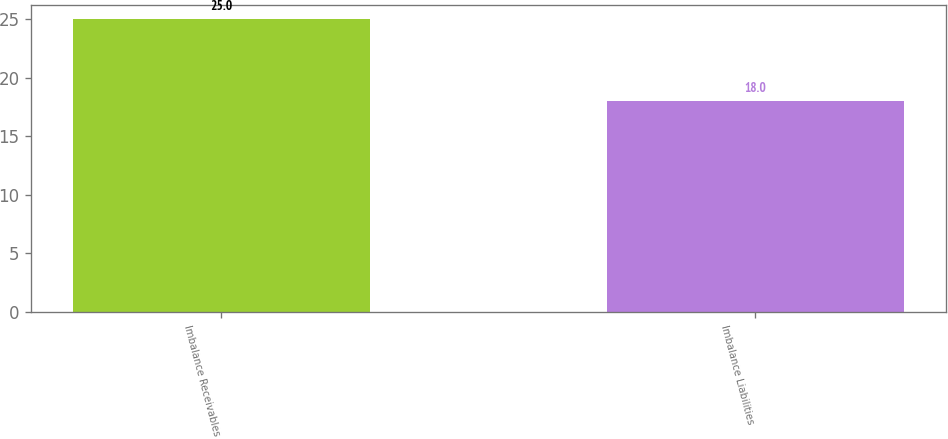Convert chart. <chart><loc_0><loc_0><loc_500><loc_500><bar_chart><fcel>Imbalance Receivables<fcel>Imbalance Liabilities<nl><fcel>25<fcel>18<nl></chart> 